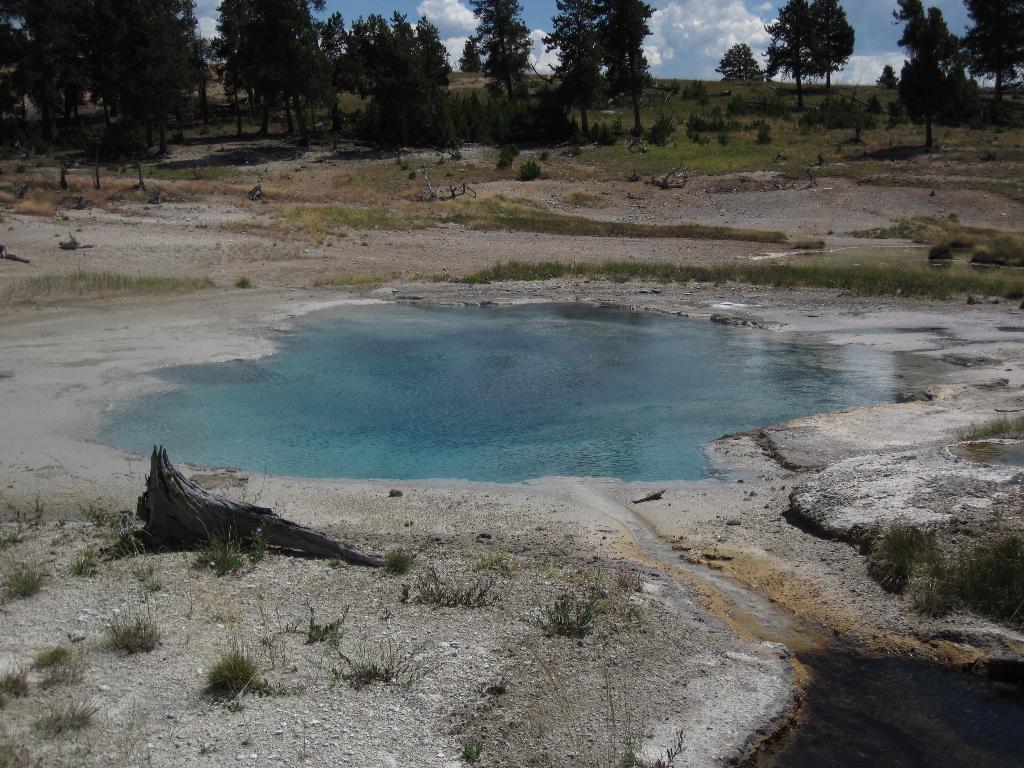In one or two sentences, can you explain what this image depicts? In this image we can see a pool of water, behind the water, there are trees as well. 